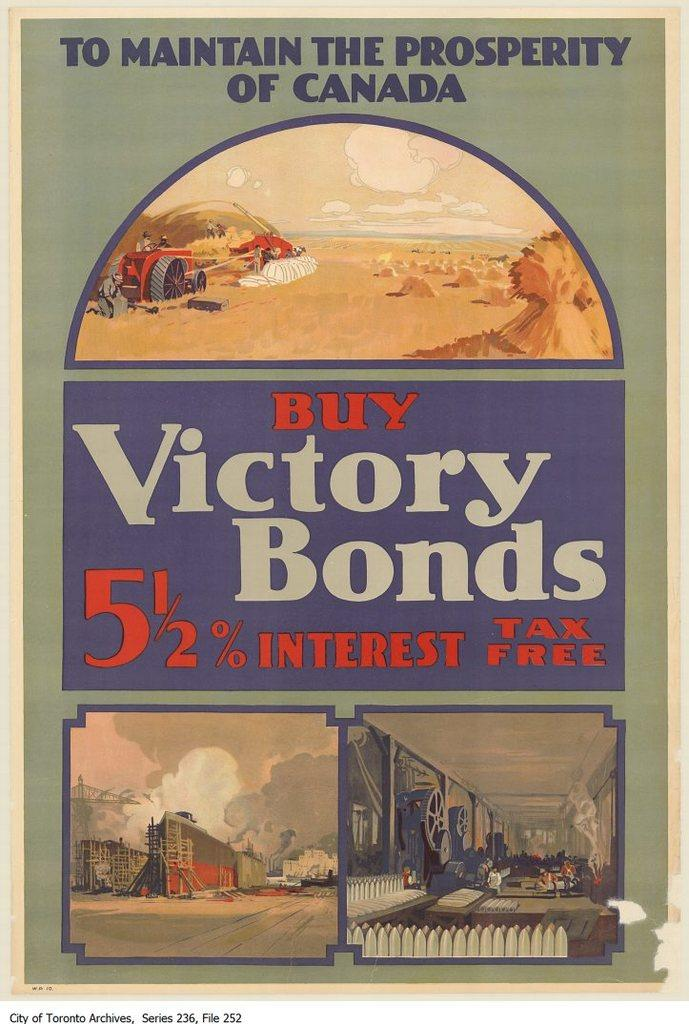What is present on the poster in the image? There is a poster in the image. What can be found on the poster besides the paintings or images? The poster contains text. How many paintings or images are included on the poster? The poster includes three paintings or images. What type of cracker is being used as a prop in the image? There is no cracker present in the image. Are there any giants visible in the image? There are no giants present in the image. 